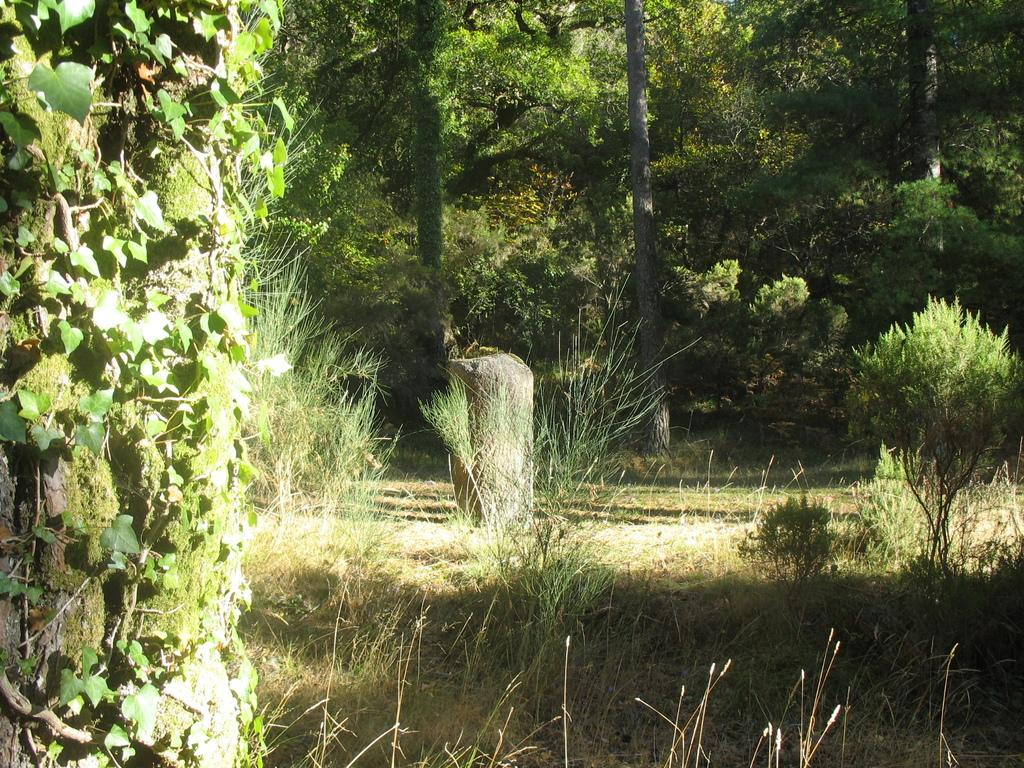What type of object can be seen in the image? There is a stone in the image. What other natural elements are present in the image? There are plants, creepers, grass, and trees visible in the image. What route does the knee take in the image? There is no knee present in the image, so it is not possible to determine a route. 